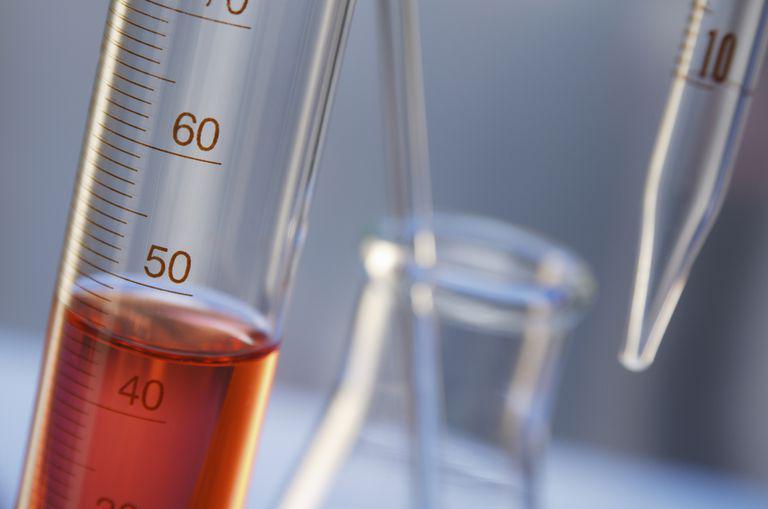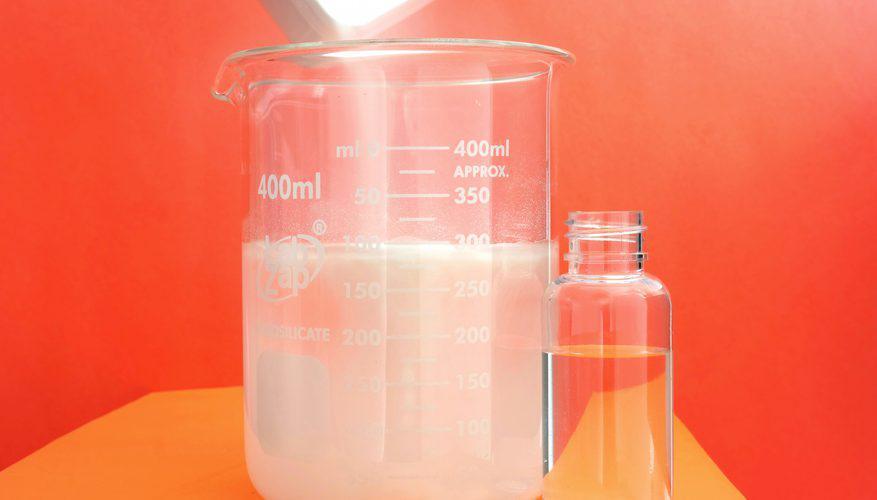The first image is the image on the left, the second image is the image on the right. Examine the images to the left and right. Is the description "There are at least four beaker." accurate? Answer yes or no. No. 